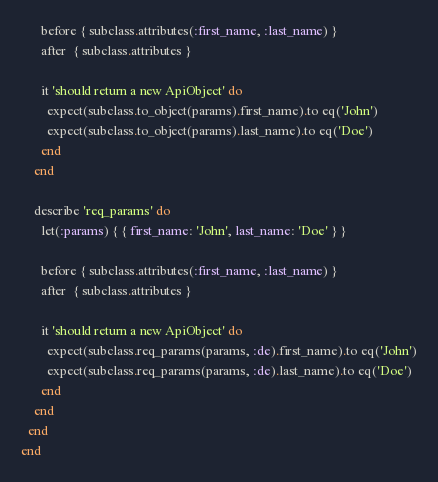Convert code to text. <code><loc_0><loc_0><loc_500><loc_500><_Ruby_>      before { subclass.attributes(:first_name, :last_name) }
      after  { subclass.attributes }

      it 'should return a new ApiObject' do
        expect(subclass.to_object(params).first_name).to eq('John')
        expect(subclass.to_object(params).last_name).to eq('Doe')
      end
    end

    describe 'req_params' do
      let(:params) { { first_name: 'John', last_name: 'Doe' } }

      before { subclass.attributes(:first_name, :last_name) }
      after  { subclass.attributes }

      it 'should return a new ApiObject' do
        expect(subclass.req_params(params, :de).first_name).to eq('John')
        expect(subclass.req_params(params, :de).last_name).to eq('Doe')
      end
    end
  end
end
</code> 